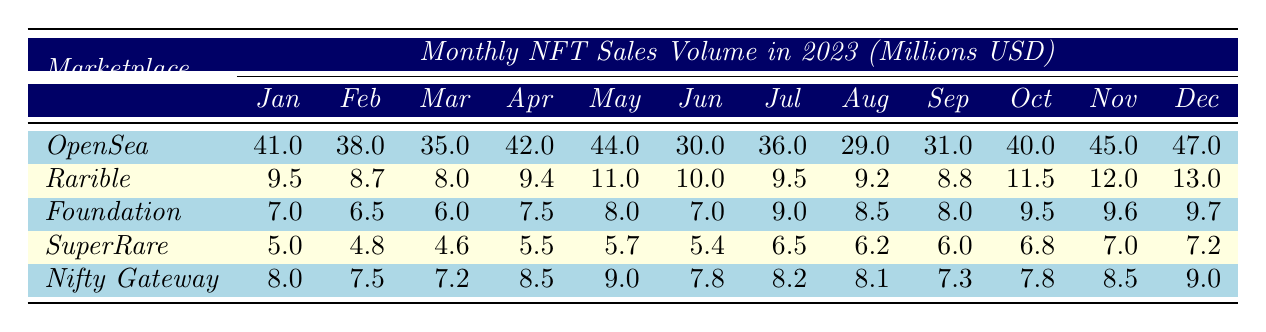What was the highest monthly sales volume for OpenSea in 2023? The highest monthly sales volume for OpenSea can be found by looking through the 12 months for the maximum value. The highest value is 47 million USD in December.
Answer: 47 million USD Which marketplace had the lowest sales volume in January? By comparing the sales volumes for January across all marketplaces, we see that SuperRare had the lowest at 5 million USD.
Answer: SuperRare What is the total sales volume of Rarible for the first half of 2023 (January to June)? To find the total for Rarible from January to June, we add the monthly values: 9.5 + 8.7 + 8.0 + 9.4 + 11.0 + 10.0 = 56.6 million USD.
Answer: 56.6 million USD What was the average monthly sales volume for Foundation across all months? To calculate the average, we sum the monthly values for Foundation and then divide by the number of months: (7 + 6.5 + 6 + 7.5 + 8 + 7 + 9 + 8.5 + 8 + 9.5 + 9.6 + 9.7) = 99.0, and average = 99.0 / 12 = 8.25 million USD.
Answer: 8.25 million USD Did Nifty Gateway achieve higher sales volume than SuperRare in any month? We compare the monthly sales figures for both Nifty Gateway and SuperRare. Nifty Gateway had higher sales than SuperRare in every month.
Answer: Yes What was the percentage change in sales volume from January to November for OpenSea? To find the percentage change, subtract January's volume from November's (45 - 41) and then divide by January's volume: (45 - 41) / 41 * 100 = 9.76%.
Answer: 9.76% Which month had the highest sales volume for Rarible and how much was it? By locating the maximum sales figure for Rarible within the table, we see that November had the highest sales volume at 12 million USD.
Answer: 12 million USD How many marketplaces had sales volumes exceeding 30 million USD in April? By inspecting the April sales, we note that OpenSea (42 million) and Rarible (9.4 million), Foundation (7.5 million), SuperRare (5.5 million), and Nifty Gateway (8.5 million) had below 30 million. Only OpenSea exceeded 30 million.
Answer: 1 Marketplace What was the difference in sales volume between the highest and lowest months for Nifty Gateway? The highest month for Nifty Gateway is May at 9 million, and the lowest is February at 7.5 million. The difference is 9 - 7.5 = 1.5 million USD.
Answer: 1.5 million USD Which marketplace showed the most consistent sales volume over the months? Observing the monthly sales trends, SuperRare's values are relatively close month-to-month, indicating more consistency than others.
Answer: SuperRare 